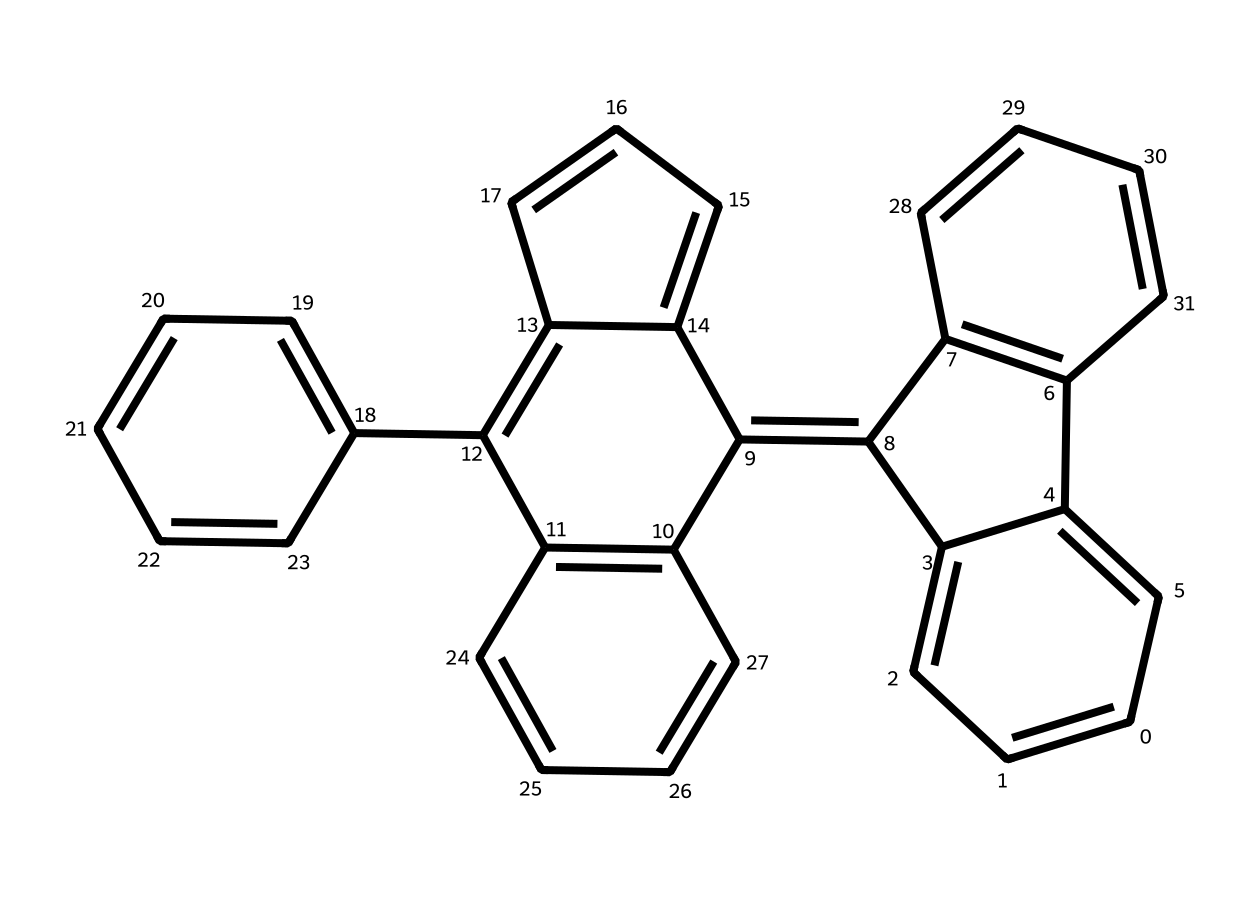What is the main element in graphene quantum dots? The structure shows only carbon atoms, indicated by the symbol 'C' throughout the SMILES representation. Therefore, carbon is the primary element in graphene quantum dots.
Answer: carbon How many rings are present in this structure? To determine the number of rings, I count the distinct cyclic components in the structure, which shows a total of 5 distinctive aromatic rings fused together.
Answer: five Is this compound likely to be soluble in water? Generally, graphene quantum dots tend to be hydrophobic due to their carbon-rich structure, lacking polar functional groups that would enhance water solubility. Thus, it's unlikely to be soluble in water.
Answer: no What unique property of quantum dots might be inferred from this structure? The presence of multiple fused rings in this structure suggests strong light absorption properties, which is a notable characteristic of quantum dots, commonly used in optoelectronic applications.
Answer: light absorption How many total carbon atoms are present in the structure? By analyzing the SMILES code provided, I can tally the number of 'C' symbols, which amounts to 30 carbon atoms in total in the structure.
Answer: thirty What type of bonding predominates in graphene quantum dots? The SMILES representation indicates a structure with numerous alternating double bonds, characteristic of aromatic compounds, suggesting that covalent bonding predominates here.
Answer: covalent Can this compound act as a semiconductor? The arrangement of carbon atoms in a graphene lattice structure gives rise to semiconducting properties, making these quantum dots suitable for electronic applications like photodetectors or solar cells.
Answer: yes 